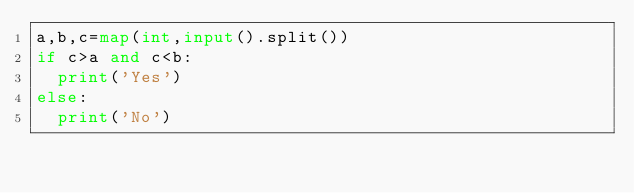Convert code to text. <code><loc_0><loc_0><loc_500><loc_500><_Python_>a,b,c=map(int,input().split())
if c>a and c<b:
  print('Yes')
else:
  print('No')</code> 